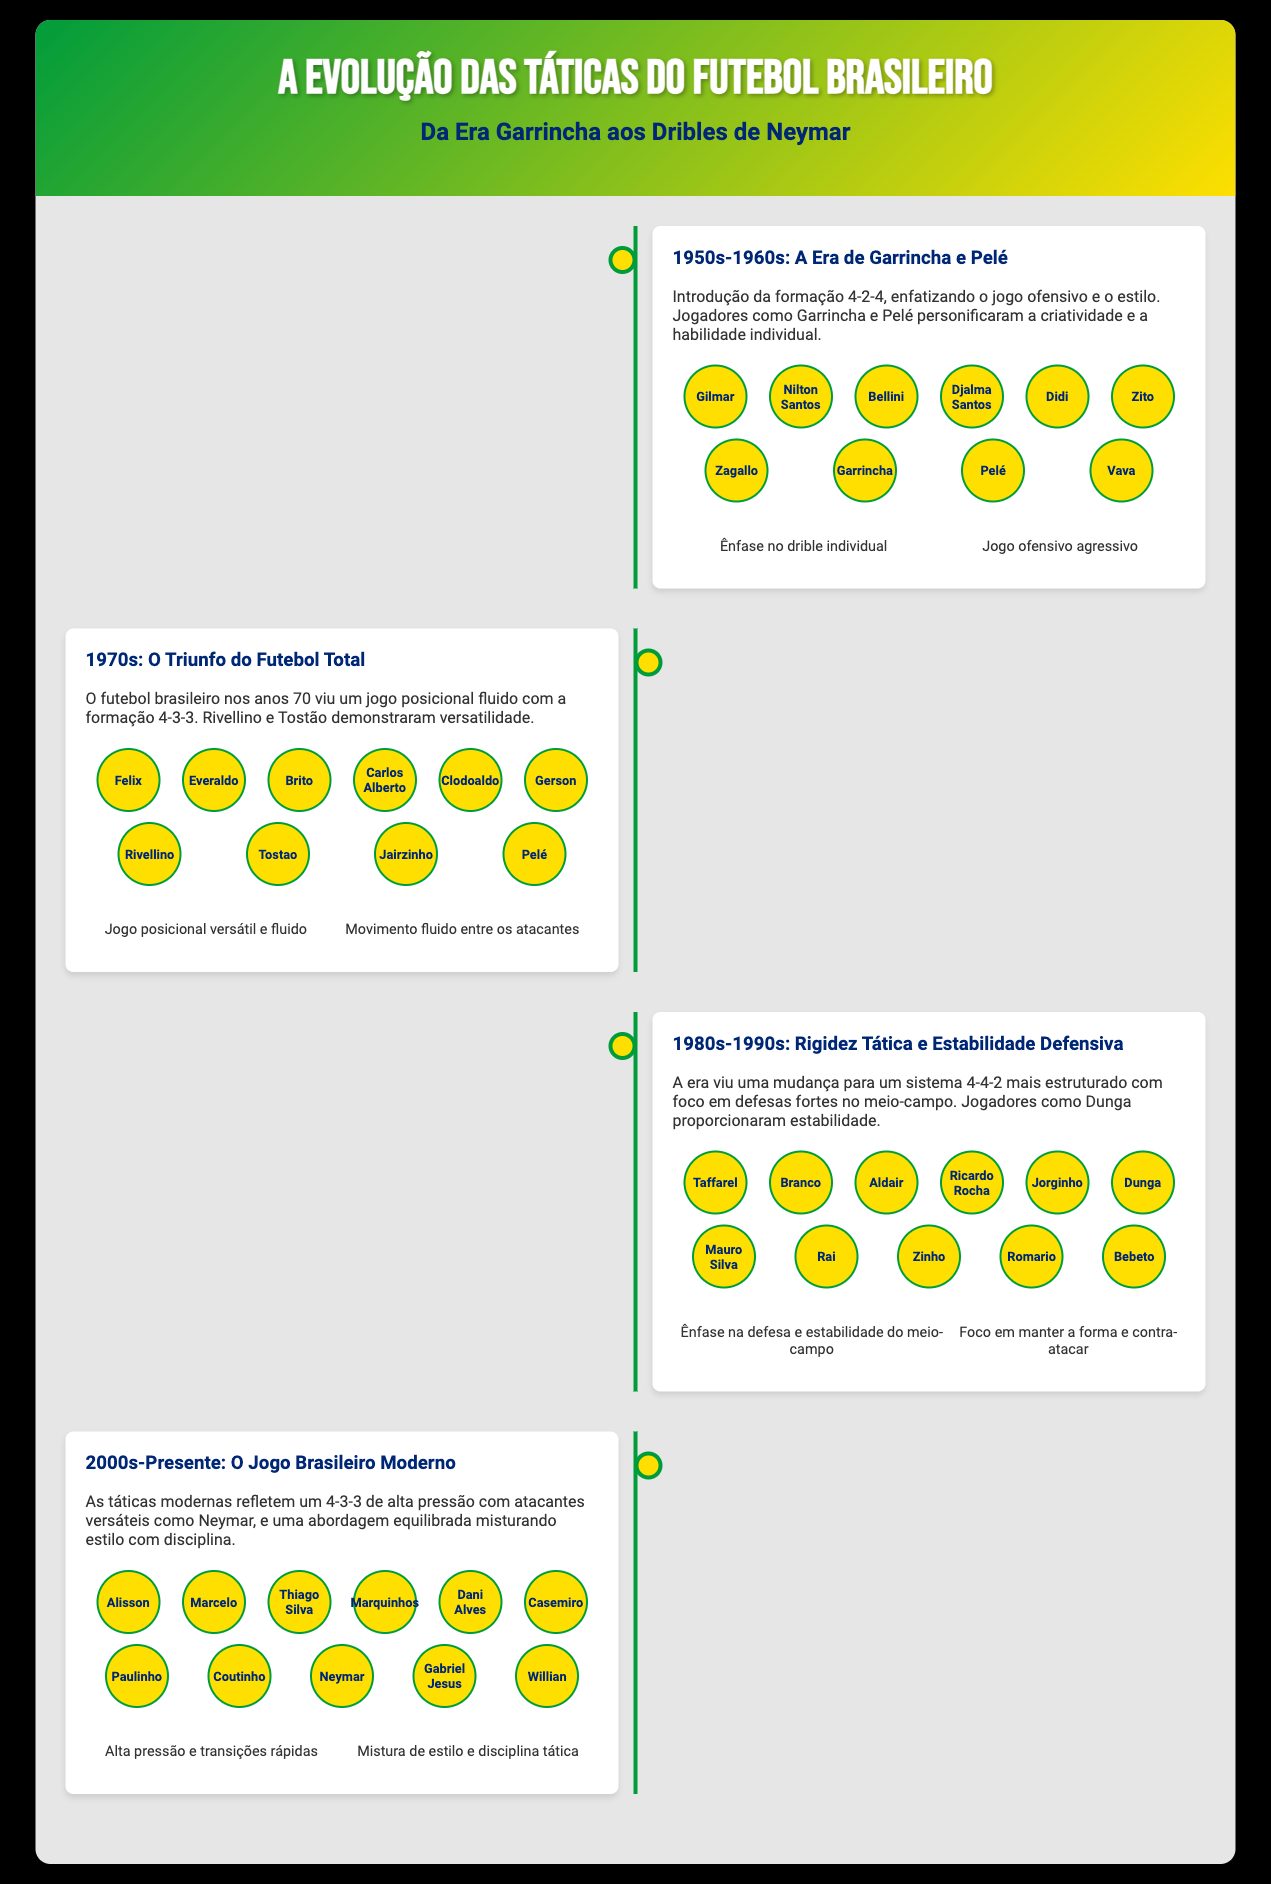What formation was introduced in the 1950s-1960s? The document states that the 4-2-4 formation was introduced, focusing on offensive play.
Answer: 4-2-4 Who were two key players in the 1970s era? The document mentions Rivellino and Tostão as demonstrations of versatility in the 1970s.
Answer: Rivellino and Tostão What was the focus of tactics in the 1980s-1990s? The document indicates that the focus shifted to a more structured 4-4-2 system with strong defensive emphasis.
Answer: Defesa Which formation reflects modern Brazilian tactics? The modern Brazilian tactics are reflected by the 4-3-3 formation, as stated in the document.
Answer: 4-3-3 What is a characteristic of the football from the 2000s to the present? According to the document, high pressure and quick transitions are characteristic of modern Brazilian football.
Answer: Alta pressão How did the style of play change from the 1960s to the 1970s? The transition from the 4-2-4 to a fluid 4-3-3 indicates a shift from rigid to more versatile positioning.
Answer: Versatilidade What do the icons in the infographic represent? The icons visualize key tactical characteristics and emphases during each era of Brazilian football, making important insights accessible.
Answer: Características táticas Who were the goalkeepers mentioned in the infographic? The document lists Gilmar, Taffarel, and Alisson as key goalkeepers in different eras of Brazilian football.
Answer: Gilmar, Taffarel, Alisson 